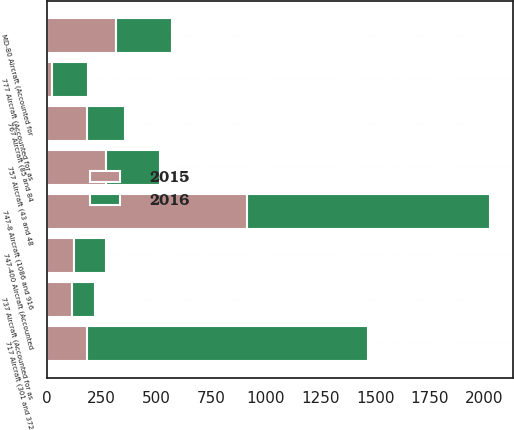Convert chart to OTSL. <chart><loc_0><loc_0><loc_500><loc_500><stacked_bar_chart><ecel><fcel>717 Aircraft (301 and 372<fcel>747-8 Aircraft (1086 and 916<fcel>MD-80 Aircraft (Accounted for<fcel>757 Aircraft (43 and 48<fcel>767 Aircraft (85 and 84<fcel>777 Aircraft (Accounted for as<fcel>747-400 Aircraft (Accounted<fcel>737 Aircraft (Accounted for as<nl><fcel>2016<fcel>1282<fcel>1111<fcel>259<fcel>246<fcel>170<fcel>165<fcel>149<fcel>103<nl><fcel>2015<fcel>185<fcel>916<fcel>314<fcel>270<fcel>185<fcel>23<fcel>122<fcel>115<nl></chart> 